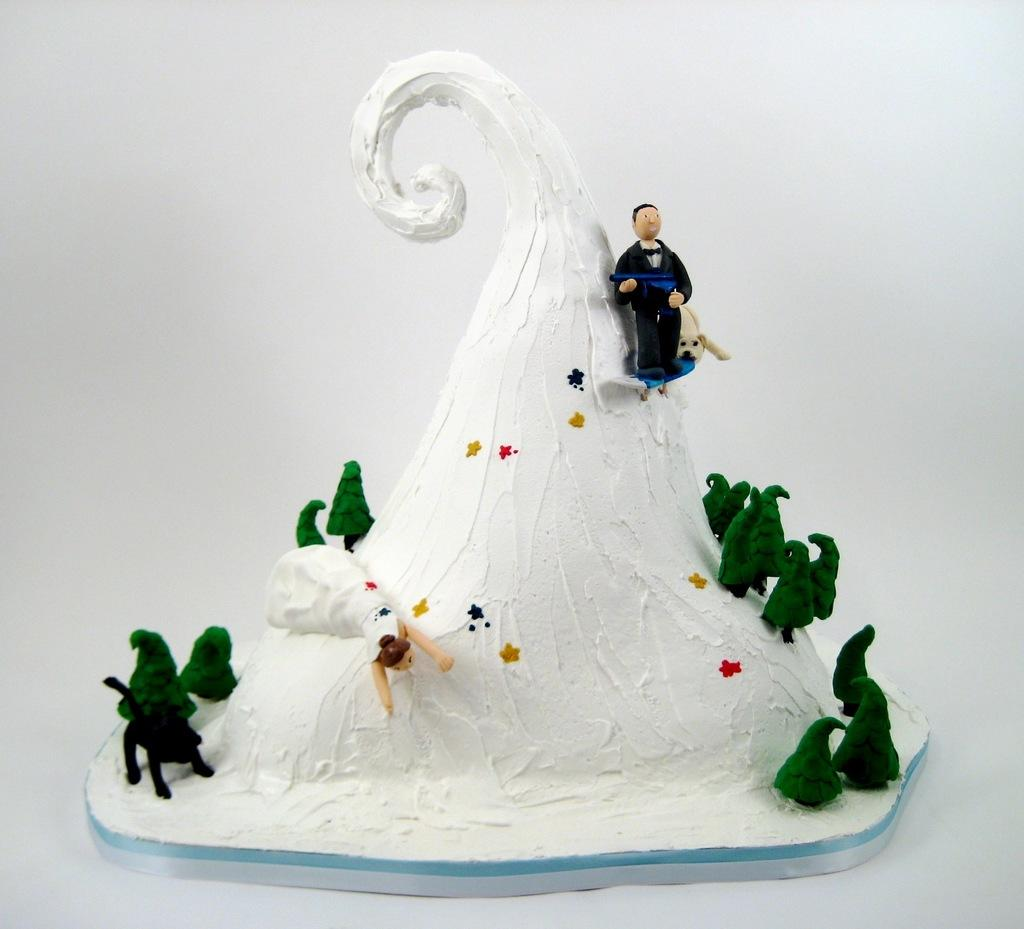What is: What is the main subject of the image? There is a cake in the image. What color is the background of the image? The background of the image is white. How many hydrants are visible in the image? There are no hydrants present in the image. What type of knot is used to decorate the cake in the image? There is no knot or any specific decoration mentioned in the image; it only states that there is a cake. 